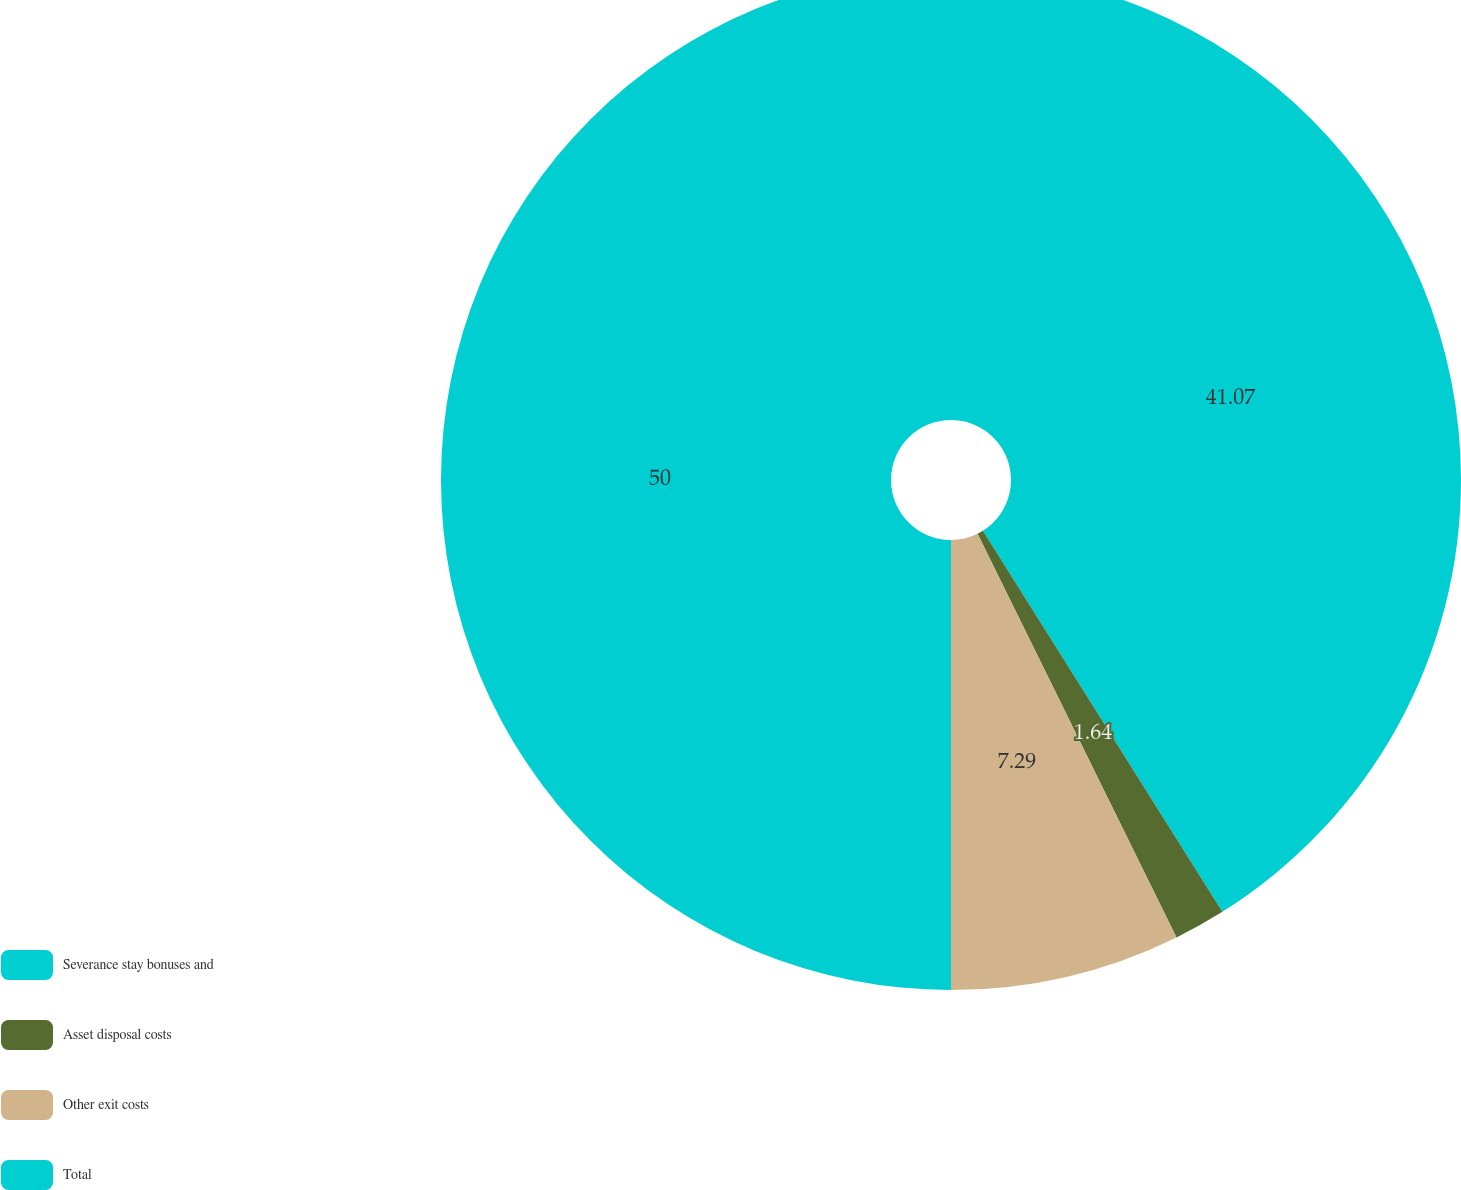<chart> <loc_0><loc_0><loc_500><loc_500><pie_chart><fcel>Severance stay bonuses and<fcel>Asset disposal costs<fcel>Other exit costs<fcel>Total<nl><fcel>41.07%<fcel>1.64%<fcel>7.29%<fcel>50.0%<nl></chart> 